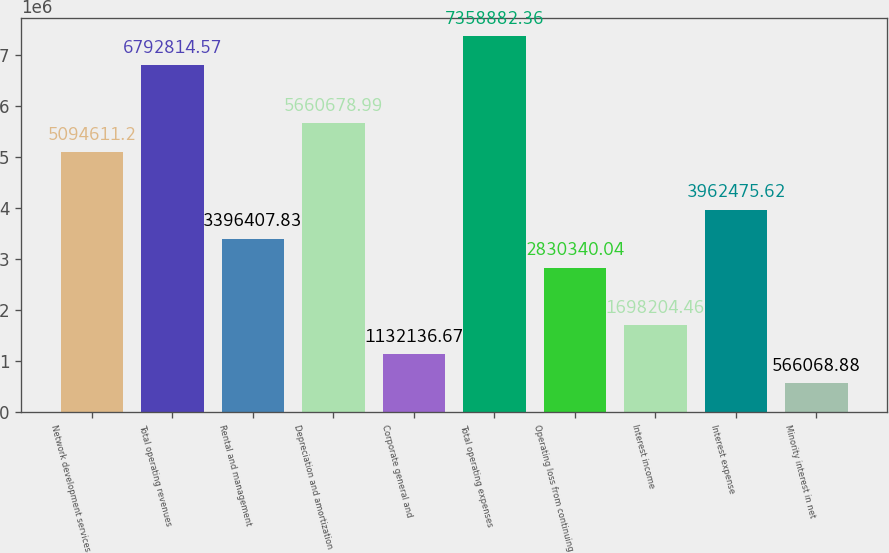Convert chart to OTSL. <chart><loc_0><loc_0><loc_500><loc_500><bar_chart><fcel>Network development services<fcel>Total operating revenues<fcel>Rental and management<fcel>Depreciation and amortization<fcel>Corporate general and<fcel>Total operating expenses<fcel>Operating loss from continuing<fcel>Interest income<fcel>Interest expense<fcel>Minority interest in net<nl><fcel>5.09461e+06<fcel>6.79281e+06<fcel>3.39641e+06<fcel>5.66068e+06<fcel>1.13214e+06<fcel>7.35888e+06<fcel>2.83034e+06<fcel>1.6982e+06<fcel>3.96248e+06<fcel>566069<nl></chart> 